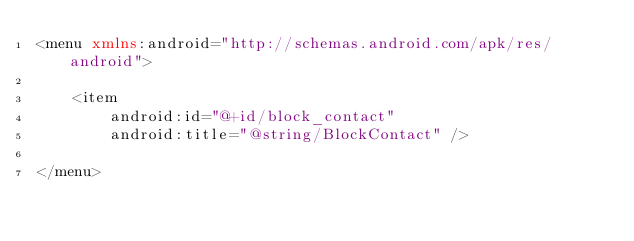<code> <loc_0><loc_0><loc_500><loc_500><_XML_><menu xmlns:android="http://schemas.android.com/apk/res/android">

    <item
        android:id="@+id/block_contact"
        android:title="@string/BlockContact" />

</menu></code> 